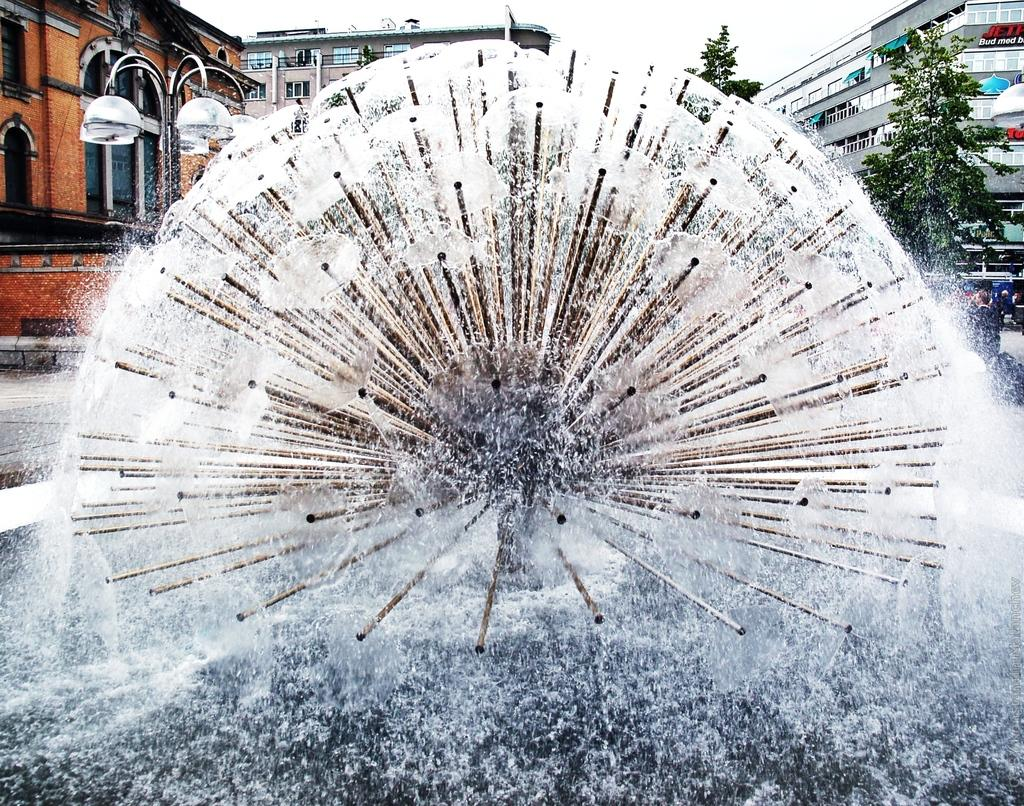What is the main subject of the image? There is a water fountain in the image. What can be seen in the background of the image? There are buildings, trees, and the sky visible in the background of the image. What type of fuel is being used by the water fountain in the image? There is no indication in the image that the water fountain uses any type of fuel; it is likely powered by water pressure. 